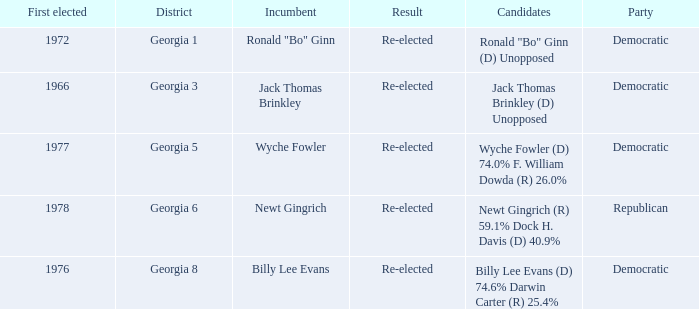What is the earliest first elected for district georgia 1? 1972.0. 